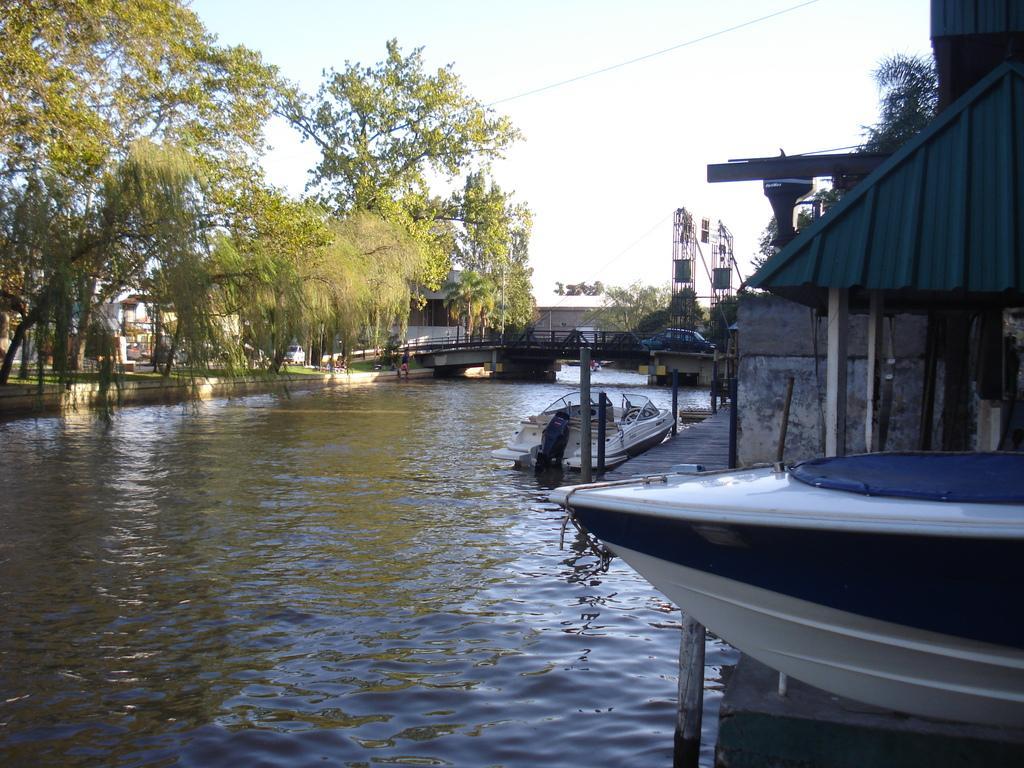Could you give a brief overview of what you see in this image? In this image there is water and we can see boats on the water. In the background there are trees and we can see a bridge. There is a car on the bridge. At the top there is sky. 